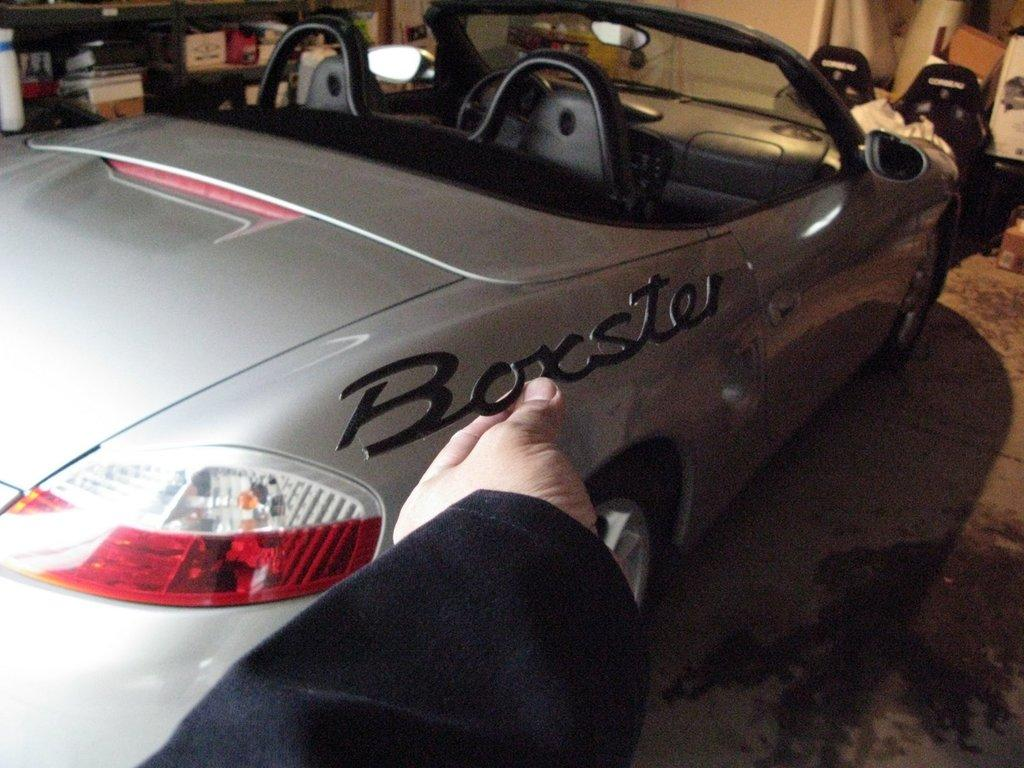What is the person holding in the image? The person is holding a vehicle name plate in the image. What type of vehicle is present in the image? There is a car in the image. What can be seen in the background of the image? There are cardboard boxes in the image. What is the purpose of the racks in the image? The racks are used to store objects, as there are objects visible in them. Can you see any giants walking through the stream in the image? There is no stream or giants present in the image. 